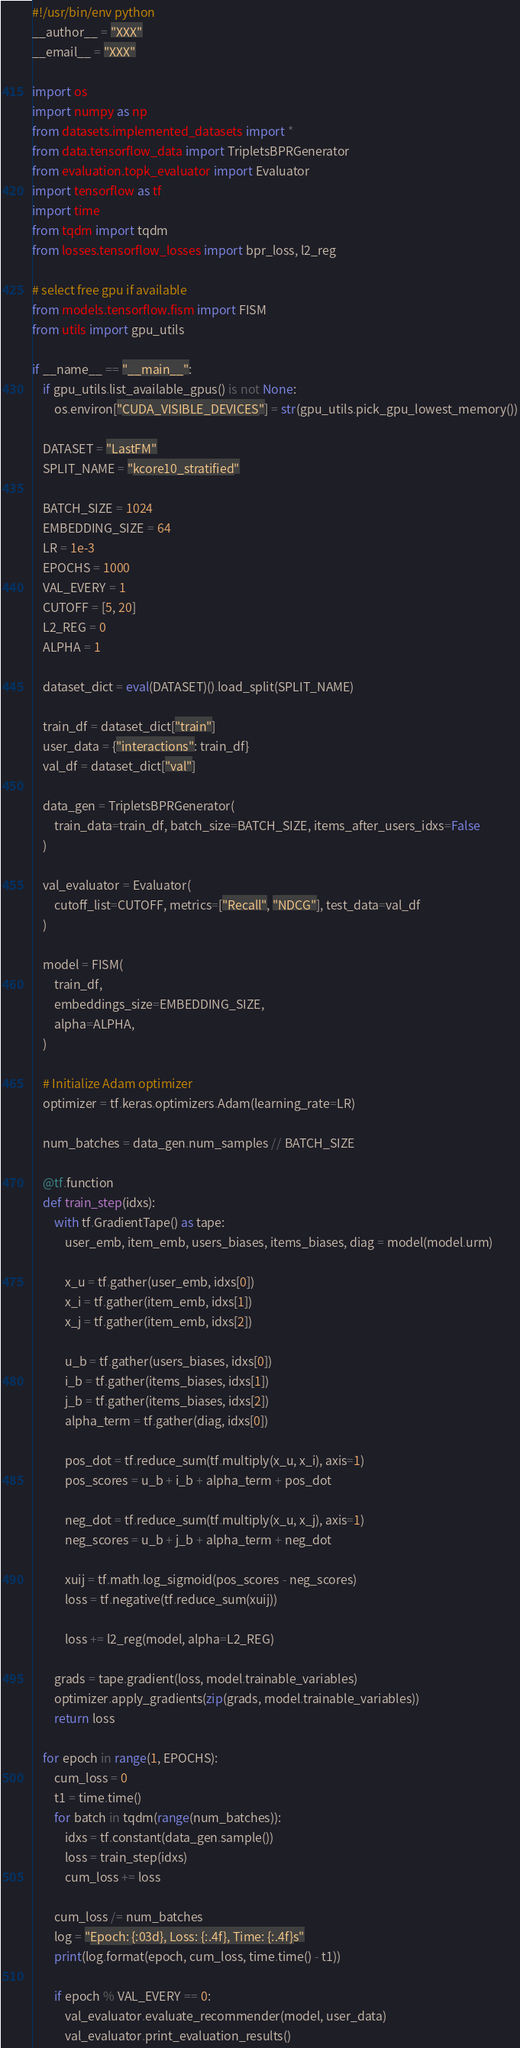<code> <loc_0><loc_0><loc_500><loc_500><_Python_>#!/usr/bin/env python
__author__ = "XXX"
__email__ = "XXX"

import os
import numpy as np
from datasets.implemented_datasets import *
from data.tensorflow_data import TripletsBPRGenerator
from evaluation.topk_evaluator import Evaluator
import tensorflow as tf
import time
from tqdm import tqdm
from losses.tensorflow_losses import bpr_loss, l2_reg

# select free gpu if available
from models.tensorflow.fism import FISM
from utils import gpu_utils

if __name__ == "__main__":
    if gpu_utils.list_available_gpus() is not None:
        os.environ["CUDA_VISIBLE_DEVICES"] = str(gpu_utils.pick_gpu_lowest_memory())

    DATASET = "LastFM"
    SPLIT_NAME = "kcore10_stratified"

    BATCH_SIZE = 1024
    EMBEDDING_SIZE = 64
    LR = 1e-3
    EPOCHS = 1000
    VAL_EVERY = 1
    CUTOFF = [5, 20]
    L2_REG = 0
    ALPHA = 1

    dataset_dict = eval(DATASET)().load_split(SPLIT_NAME)

    train_df = dataset_dict["train"]
    user_data = {"interactions": train_df}
    val_df = dataset_dict["val"]

    data_gen = TripletsBPRGenerator(
        train_data=train_df, batch_size=BATCH_SIZE, items_after_users_idxs=False
    )

    val_evaluator = Evaluator(
        cutoff_list=CUTOFF, metrics=["Recall", "NDCG"], test_data=val_df
    )

    model = FISM(
        train_df,
        embeddings_size=EMBEDDING_SIZE,
        alpha=ALPHA,
    )

    # Initialize Adam optimizer
    optimizer = tf.keras.optimizers.Adam(learning_rate=LR)

    num_batches = data_gen.num_samples // BATCH_SIZE

    @tf.function
    def train_step(idxs):
        with tf.GradientTape() as tape:
            user_emb, item_emb, users_biases, items_biases, diag = model(model.urm)

            x_u = tf.gather(user_emb, idxs[0])
            x_i = tf.gather(item_emb, idxs[1])
            x_j = tf.gather(item_emb, idxs[2])

            u_b = tf.gather(users_biases, idxs[0])
            i_b = tf.gather(items_biases, idxs[1])
            j_b = tf.gather(items_biases, idxs[2])
            alpha_term = tf.gather(diag, idxs[0])

            pos_dot = tf.reduce_sum(tf.multiply(x_u, x_i), axis=1)
            pos_scores = u_b + i_b + alpha_term + pos_dot

            neg_dot = tf.reduce_sum(tf.multiply(x_u, x_j), axis=1)
            neg_scores = u_b + j_b + alpha_term + neg_dot

            xuij = tf.math.log_sigmoid(pos_scores - neg_scores)
            loss = tf.negative(tf.reduce_sum(xuij))

            loss += l2_reg(model, alpha=L2_REG)

        grads = tape.gradient(loss, model.trainable_variables)
        optimizer.apply_gradients(zip(grads, model.trainable_variables))
        return loss

    for epoch in range(1, EPOCHS):
        cum_loss = 0
        t1 = time.time()
        for batch in tqdm(range(num_batches)):
            idxs = tf.constant(data_gen.sample())
            loss = train_step(idxs)
            cum_loss += loss

        cum_loss /= num_batches
        log = "Epoch: {:03d}, Loss: {:.4f}, Time: {:.4f}s"
        print(log.format(epoch, cum_loss, time.time() - t1))

        if epoch % VAL_EVERY == 0:
            val_evaluator.evaluate_recommender(model, user_data)
            val_evaluator.print_evaluation_results()
</code> 